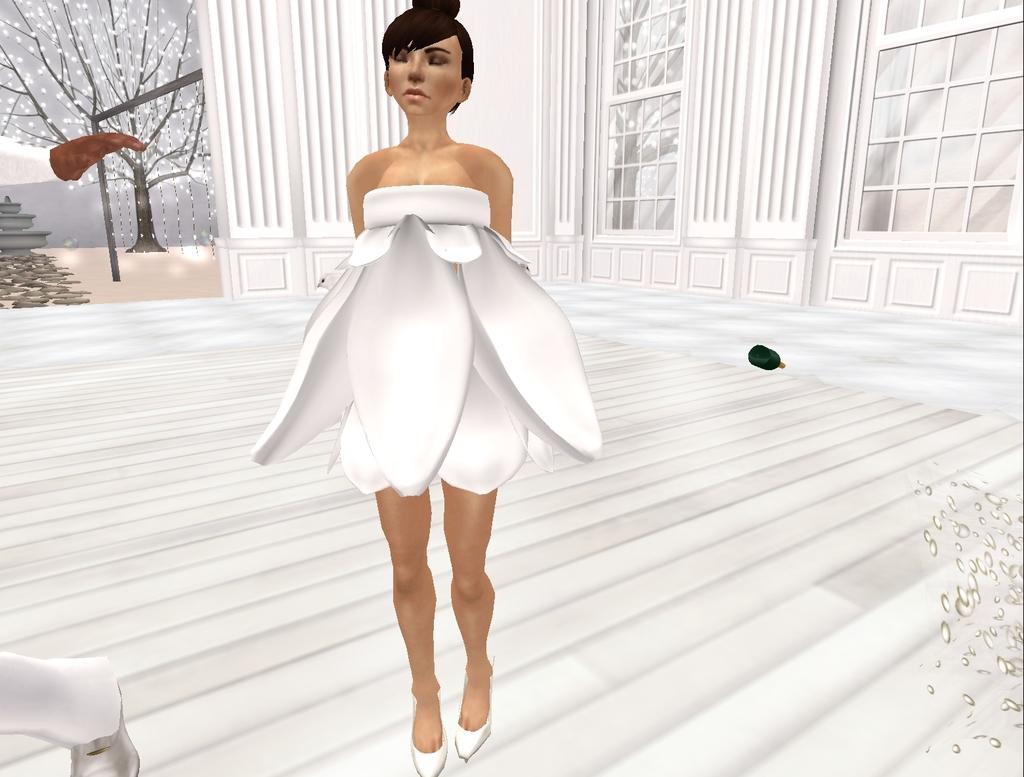What is the woman in the image wearing? The woman is wearing a white dress in the image. Where is the woman located in the image? The woman is on the floor in the image. What can be seen in the background of the image? There are windows visible in the background of the image. What is present in the image besides the woman? There is a tree and a bottle on the floor in the image. What type of design is the woman creating on the mountain in the image? There is no mountain present in the image, and the woman is not creating any design. 